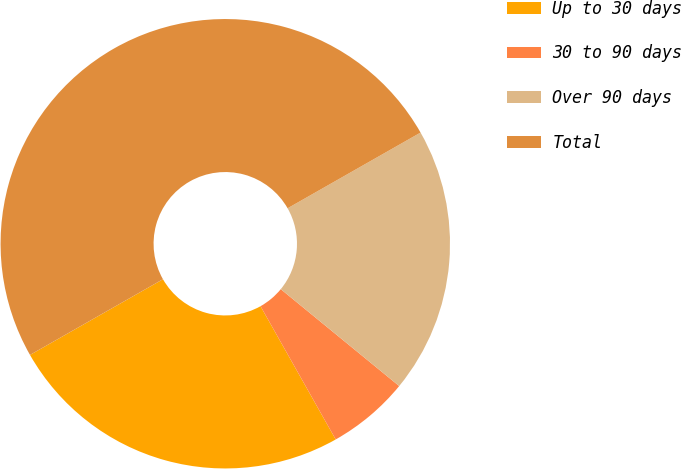Convert chart. <chart><loc_0><loc_0><loc_500><loc_500><pie_chart><fcel>Up to 30 days<fcel>30 to 90 days<fcel>Over 90 days<fcel>Total<nl><fcel>24.94%<fcel>5.91%<fcel>19.15%<fcel>50.0%<nl></chart> 